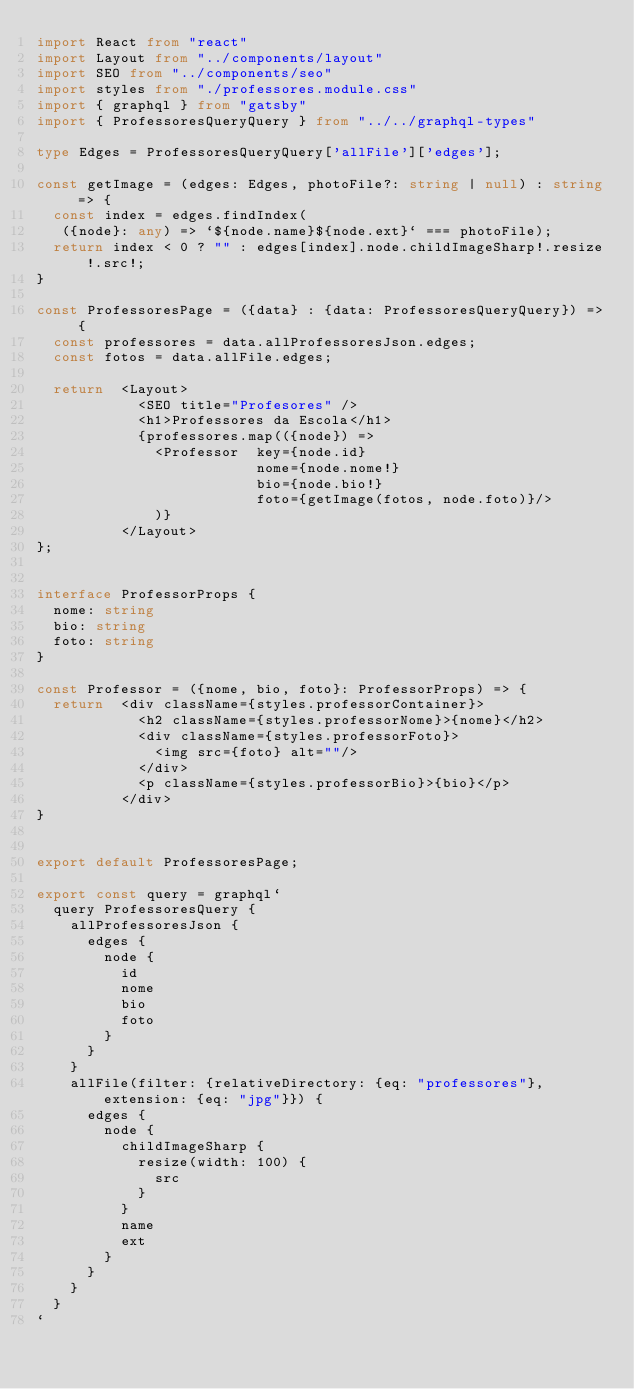<code> <loc_0><loc_0><loc_500><loc_500><_TypeScript_>import React from "react"
import Layout from "../components/layout"
import SEO from "../components/seo"
import styles from "./professores.module.css"
import { graphql } from "gatsby"
import { ProfessoresQueryQuery } from "../../graphql-types"

type Edges = ProfessoresQueryQuery['allFile']['edges'];

const getImage = (edges: Edges, photoFile?: string | null) : string => {
  const index = edges.findIndex( 
   ({node}: any) => `${node.name}${node.ext}` === photoFile);
  return index < 0 ? "" : edges[index].node.childImageSharp!.resize!.src!;
}

const ProfessoresPage = ({data} : {data: ProfessoresQueryQuery}) => {
  const professores = data.allProfessoresJson.edges;
  const fotos = data.allFile.edges;

  return  <Layout>
            <SEO title="Profesores" />
            <h1>Professores da Escola</h1>
            {professores.map(({node}) => 
              <Professor  key={node.id}
                          nome={node.nome!}
                          bio={node.bio!}
                          foto={getImage(fotos, node.foto)}/>
              )}
          </Layout>
};


interface ProfessorProps {
  nome: string
  bio: string
  foto: string
}

const Professor = ({nome, bio, foto}: ProfessorProps) => {
  return  <div className={styles.professorContainer}>
            <h2 className={styles.professorNome}>{nome}</h2>
            <div className={styles.professorFoto}>
              <img src={foto} alt=""/>
            </div>
            <p className={styles.professorBio}>{bio}</p>
          </div> 
}


export default ProfessoresPage;

export const query = graphql`
  query ProfessoresQuery {
    allProfessoresJson {
      edges {
        node {
          id
          nome
          bio
          foto
        }
      }
    }
    allFile(filter: {relativeDirectory: {eq: "professores"}, extension: {eq: "jpg"}}) {
      edges {
        node {
          childImageSharp {
            resize(width: 100) {
              src
            }
          }
          name
          ext
        }
      }
    }
  }
`



</code> 